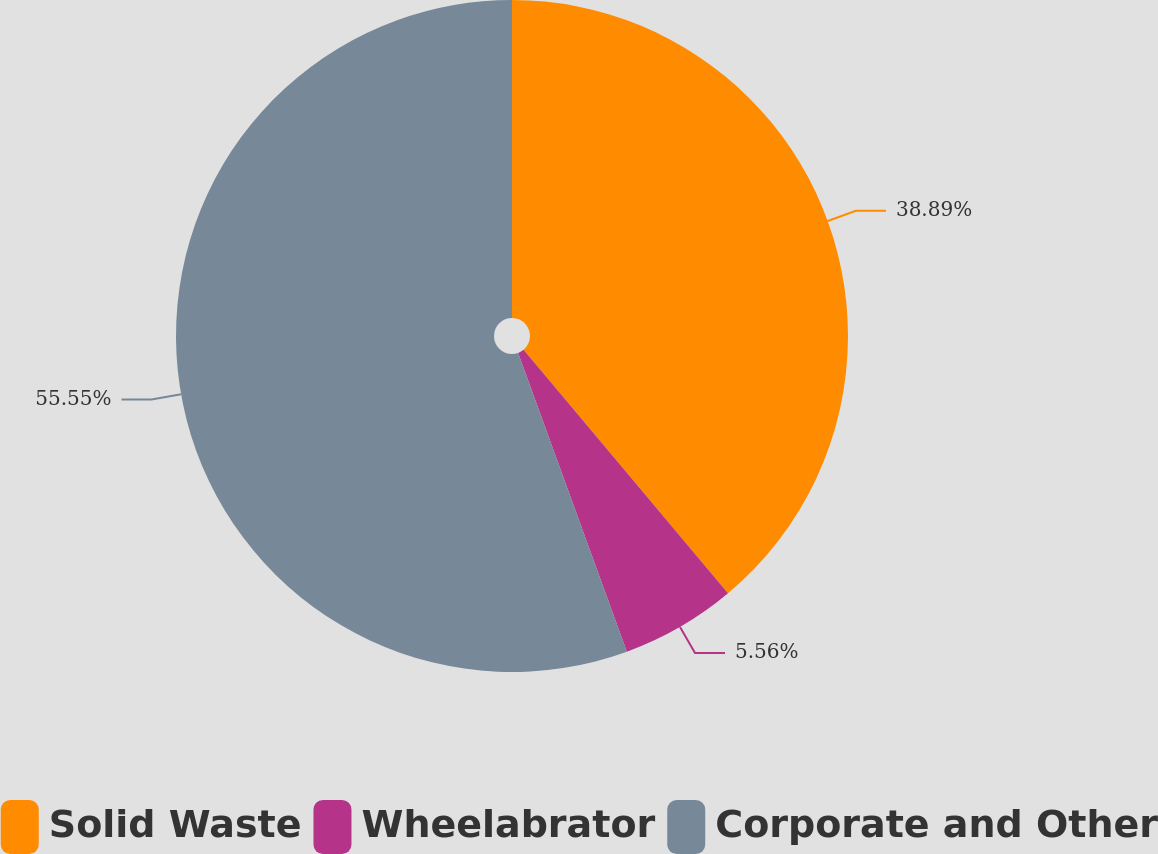Convert chart. <chart><loc_0><loc_0><loc_500><loc_500><pie_chart><fcel>Solid Waste<fcel>Wheelabrator<fcel>Corporate and Other<nl><fcel>38.89%<fcel>5.56%<fcel>55.56%<nl></chart> 